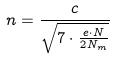Convert formula to latex. <formula><loc_0><loc_0><loc_500><loc_500>n = \frac { c } { \sqrt { 7 \cdot \frac { e \cdot N } { 2 N _ { m } } } }</formula> 